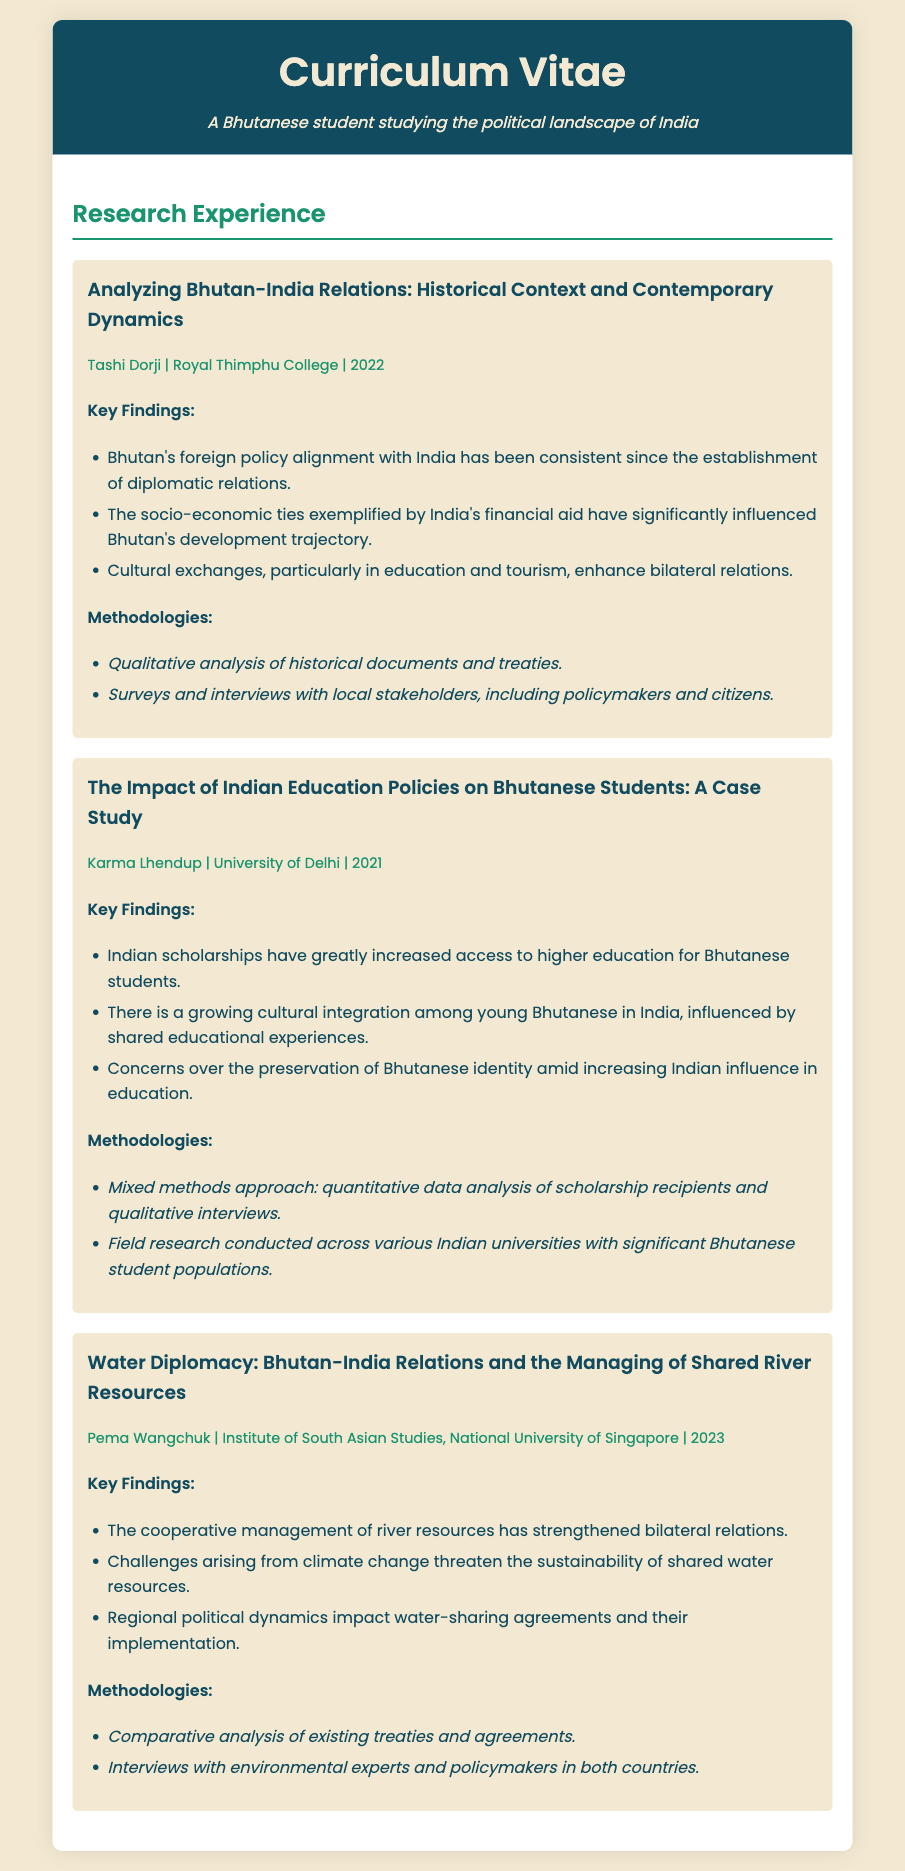what is the title of the first research project? The title of the first research project is prominently displayed at the beginning of the project section.
Answer: Analyzing Bhutan-India Relations: Historical Context and Contemporary Dynamics who conducted the second research project? The name of the individual who conducted the second research project is listed in the project info section.
Answer: Karma Lhendup what is the year of completion for the project on water diplomacy? The year of completion is included in the project details.
Answer: 2023 how many key findings are presented in the project about Indian education policies? The number of key findings can be determined by counting the bullet points under that project.
Answer: Three which methodology was used in the first research project? The specific methodology is detailed in the methodologies section of the project.
Answer: Qualitative analysis of historical documents and treaties what is the focus of the third research project? The focus of the third research project is mentioned in the title of the project.
Answer: Water Diplomacy what is a common theme in the findings of the three projects? A theme can be inferred from the key findings of each project that relate to Bhutan-India relations.
Answer: Strengthening bilateral relations what type of analysis was used in the project about Bhutanese students? The type of analysis is specified within the methodologies of the project.
Answer: Mixed methods approach 